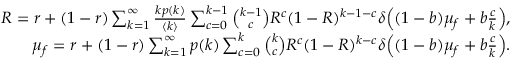Convert formula to latex. <formula><loc_0><loc_0><loc_500><loc_500>\begin{array} { r } { R = r + ( 1 - r ) \sum _ { k = 1 } ^ { \infty } \frac { k p ( k ) } { \langle k \rangle } \sum _ { c = 0 } ^ { k - 1 } \binom { k - 1 } { c } R ^ { c } ( 1 - R ) ^ { k - 1 - c } \delta \left ( ( 1 - b ) \mu _ { f } + b \frac { c } { k } \right ) , } \\ { \mu _ { f } = r + ( 1 - r ) \sum _ { k = 1 } ^ { \infty } p ( k ) \sum _ { c = 0 } ^ { k } \binom { k } { c } R ^ { c } ( 1 - R ) ^ { k - c } \delta \left ( ( 1 - b ) \mu _ { f } + b \frac { c } { k } \right ) . } \end{array}</formula> 